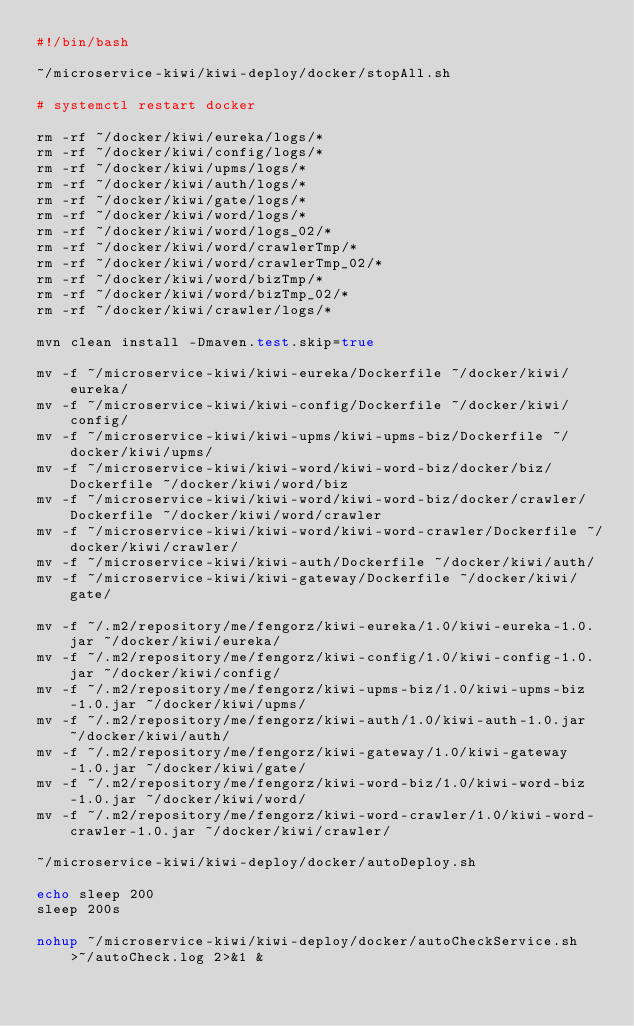Convert code to text. <code><loc_0><loc_0><loc_500><loc_500><_Bash_>#!/bin/bash

~/microservice-kiwi/kiwi-deploy/docker/stopAll.sh

# systemctl restart docker

rm -rf ~/docker/kiwi/eureka/logs/*
rm -rf ~/docker/kiwi/config/logs/*
rm -rf ~/docker/kiwi/upms/logs/*
rm -rf ~/docker/kiwi/auth/logs/*
rm -rf ~/docker/kiwi/gate/logs/*
rm -rf ~/docker/kiwi/word/logs/*
rm -rf ~/docker/kiwi/word/logs_02/*
rm -rf ~/docker/kiwi/word/crawlerTmp/*
rm -rf ~/docker/kiwi/word/crawlerTmp_02/*
rm -rf ~/docker/kiwi/word/bizTmp/*
rm -rf ~/docker/kiwi/word/bizTmp_02/*
rm -rf ~/docker/kiwi/crawler/logs/*

mvn clean install -Dmaven.test.skip=true

mv -f ~/microservice-kiwi/kiwi-eureka/Dockerfile ~/docker/kiwi/eureka/
mv -f ~/microservice-kiwi/kiwi-config/Dockerfile ~/docker/kiwi/config/
mv -f ~/microservice-kiwi/kiwi-upms/kiwi-upms-biz/Dockerfile ~/docker/kiwi/upms/
mv -f ~/microservice-kiwi/kiwi-word/kiwi-word-biz/docker/biz/Dockerfile ~/docker/kiwi/word/biz
mv -f ~/microservice-kiwi/kiwi-word/kiwi-word-biz/docker/crawler/Dockerfile ~/docker/kiwi/word/crawler
mv -f ~/microservice-kiwi/kiwi-word/kiwi-word-crawler/Dockerfile ~/docker/kiwi/crawler/
mv -f ~/microservice-kiwi/kiwi-auth/Dockerfile ~/docker/kiwi/auth/
mv -f ~/microservice-kiwi/kiwi-gateway/Dockerfile ~/docker/kiwi/gate/

mv -f ~/.m2/repository/me/fengorz/kiwi-eureka/1.0/kiwi-eureka-1.0.jar ~/docker/kiwi/eureka/
mv -f ~/.m2/repository/me/fengorz/kiwi-config/1.0/kiwi-config-1.0.jar ~/docker/kiwi/config/
mv -f ~/.m2/repository/me/fengorz/kiwi-upms-biz/1.0/kiwi-upms-biz-1.0.jar ~/docker/kiwi/upms/
mv -f ~/.m2/repository/me/fengorz/kiwi-auth/1.0/kiwi-auth-1.0.jar ~/docker/kiwi/auth/
mv -f ~/.m2/repository/me/fengorz/kiwi-gateway/1.0/kiwi-gateway-1.0.jar ~/docker/kiwi/gate/
mv -f ~/.m2/repository/me/fengorz/kiwi-word-biz/1.0/kiwi-word-biz-1.0.jar ~/docker/kiwi/word/
mv -f ~/.m2/repository/me/fengorz/kiwi-word-crawler/1.0/kiwi-word-crawler-1.0.jar ~/docker/kiwi/crawler/

~/microservice-kiwi/kiwi-deploy/docker/autoDeploy.sh

echo sleep 200
sleep 200s

nohup ~/microservice-kiwi/kiwi-deploy/docker/autoCheckService.sh  >~/autoCheck.log 2>&1 &</code> 